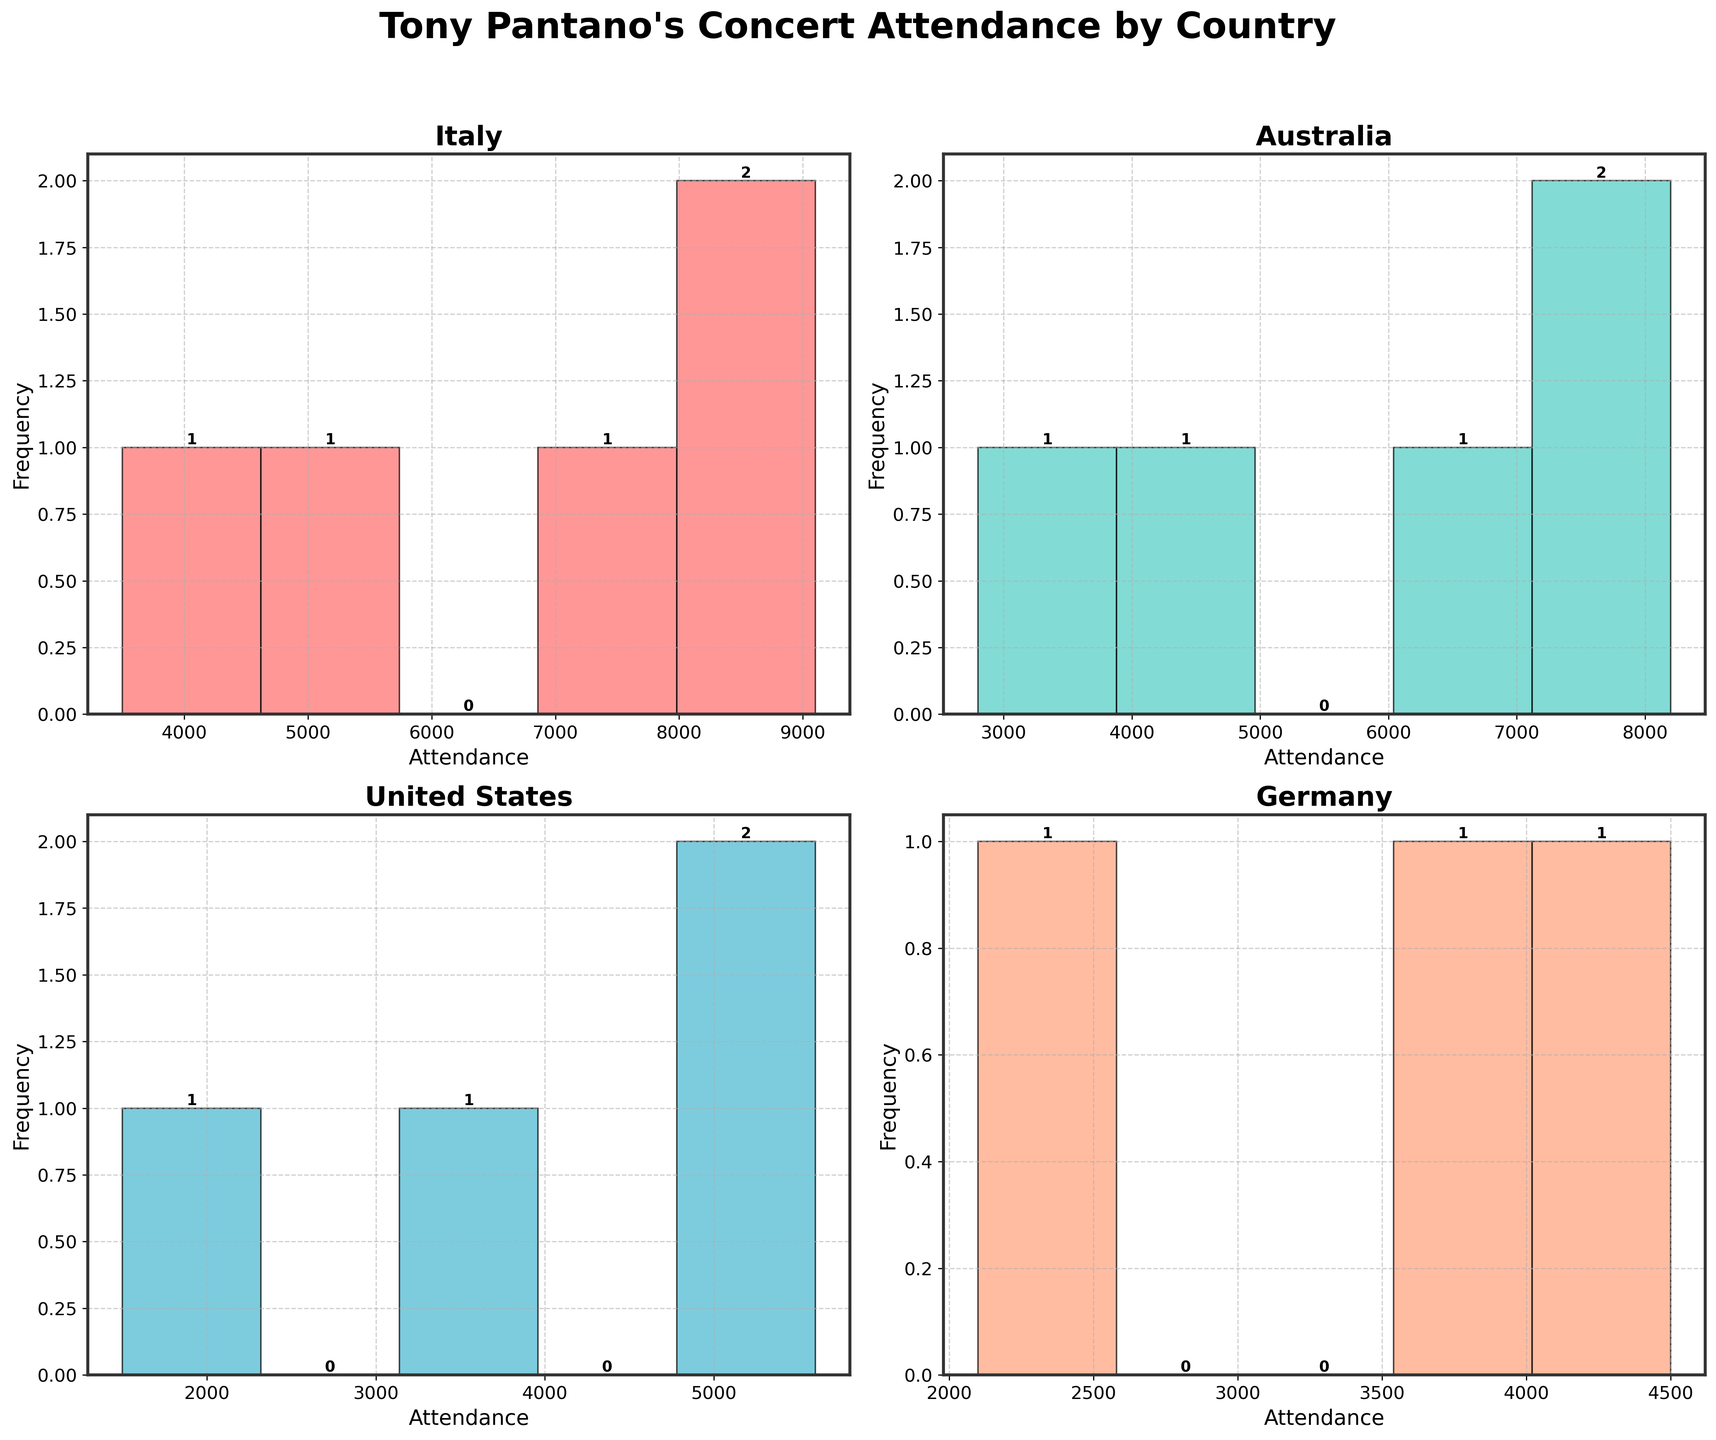How many subplots are there in the figure? The figure contains subplots for different countries showing concert attendance. Since there are 4 countries (Italy, Australia, United States, Germany), the figure has 4 subplots.
Answer: 4 What is the title of the figure? The title can be found at the top of the figure in bold text. It reads, "Tony Pantano's Concert Attendance by Country".
Answer: Tony Pantano's Concert Attendance by Country Which country had the highest concert attendance in 1990? By looking at the subplots, the histogram for each country displays the attendance data. The highest attendance in 1990 is visible in the Italy subplot, where Italy has an attendance of 9100 in 1990.
Answer: Italy Which histogram has the most frequent attendance value, and what is that value? Each histogram displays different attendance frequencies. The histogram for Italy shows a bar with the highest height, indicating this country's most frequent attendance value is around 9100 (the top bar).
Answer: Italy, 9100 What is the overall trend in concert attendance in Italy between 1975 and 1995? Observing the Italy subplot, the attendance values increase from 3500 in 1975 to a peak of 9100 in 1990, then slightly decrease to 8600 in 1995. Therefore, the trend generally indicates an increase over this period.
Answer: Increasing trend Compare the attendance trends in Australia and the United States. Which country shows more consistency in attendance? Looking at the subplots for Australia and the United States, Australia's attendance values gradually increase from 2800 in 1975 to 8200 in 1995. The United States shows a more irregular and lower range of attendance values from 1500 in 1980 to 5600 in 1995. Australia's trend is more consistent since the values have a steady rise.
Answer: Australia Which country had the lowest concert attendance overall, and what was the attendance figure? From viewing the histograms, the lowest attendance figure is depicted in the United States subplot with an attendance of 1500 in 1980.
Answer: United States, 1500 Calculate the average concert attendance for Germany in the data provided. Adding the concert attendance figures for Germany (2100 in 1985, 3700 in 1990, and 4500 in 1995) results in a total of 10300. Dividing 10300 by the number of data points (3) gives us an average attendance of approximately 3433.33.
Answer: 3433.33 How does the highest attendance in Australia compare to the highest attendance in Italy? The highest attendance in Australia is 8200 in 1995, while in Italy, it is 9100 in 1990. Comparing these figures, the highest attendance in Australia is slightly lower than the highest attendance in Italy.
Answer: Australia is lower What can you infer about Tony Pantano's popularity trends in the United States compared to Germany? Looking at the histograms, the United States shows lower concert attendance figures (highest is 5600) compared to Germany's highest of 4500. However, Germany's figures also show a more consistent growth pattern, indicating a growing popularity over time, whereas the United States shows a more scattered pattern. Thus, infering popularity growth is more stable in Germany compared to the United States.
Answer: Steady growth in Germany, scattered pattern in the United States 